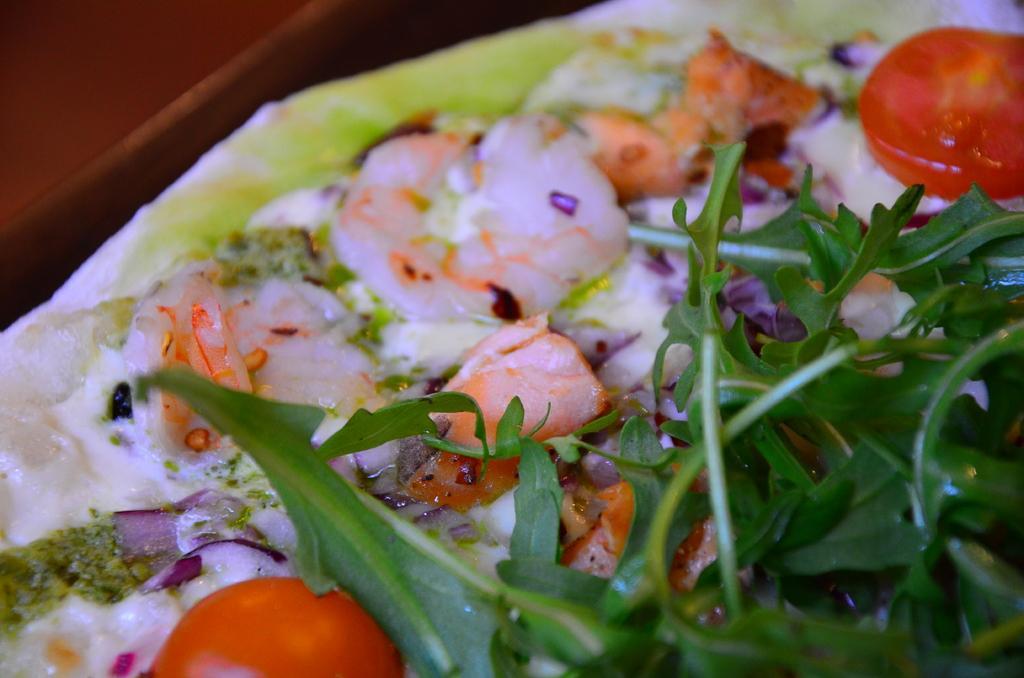Please provide a concise description of this image. There are food items. 